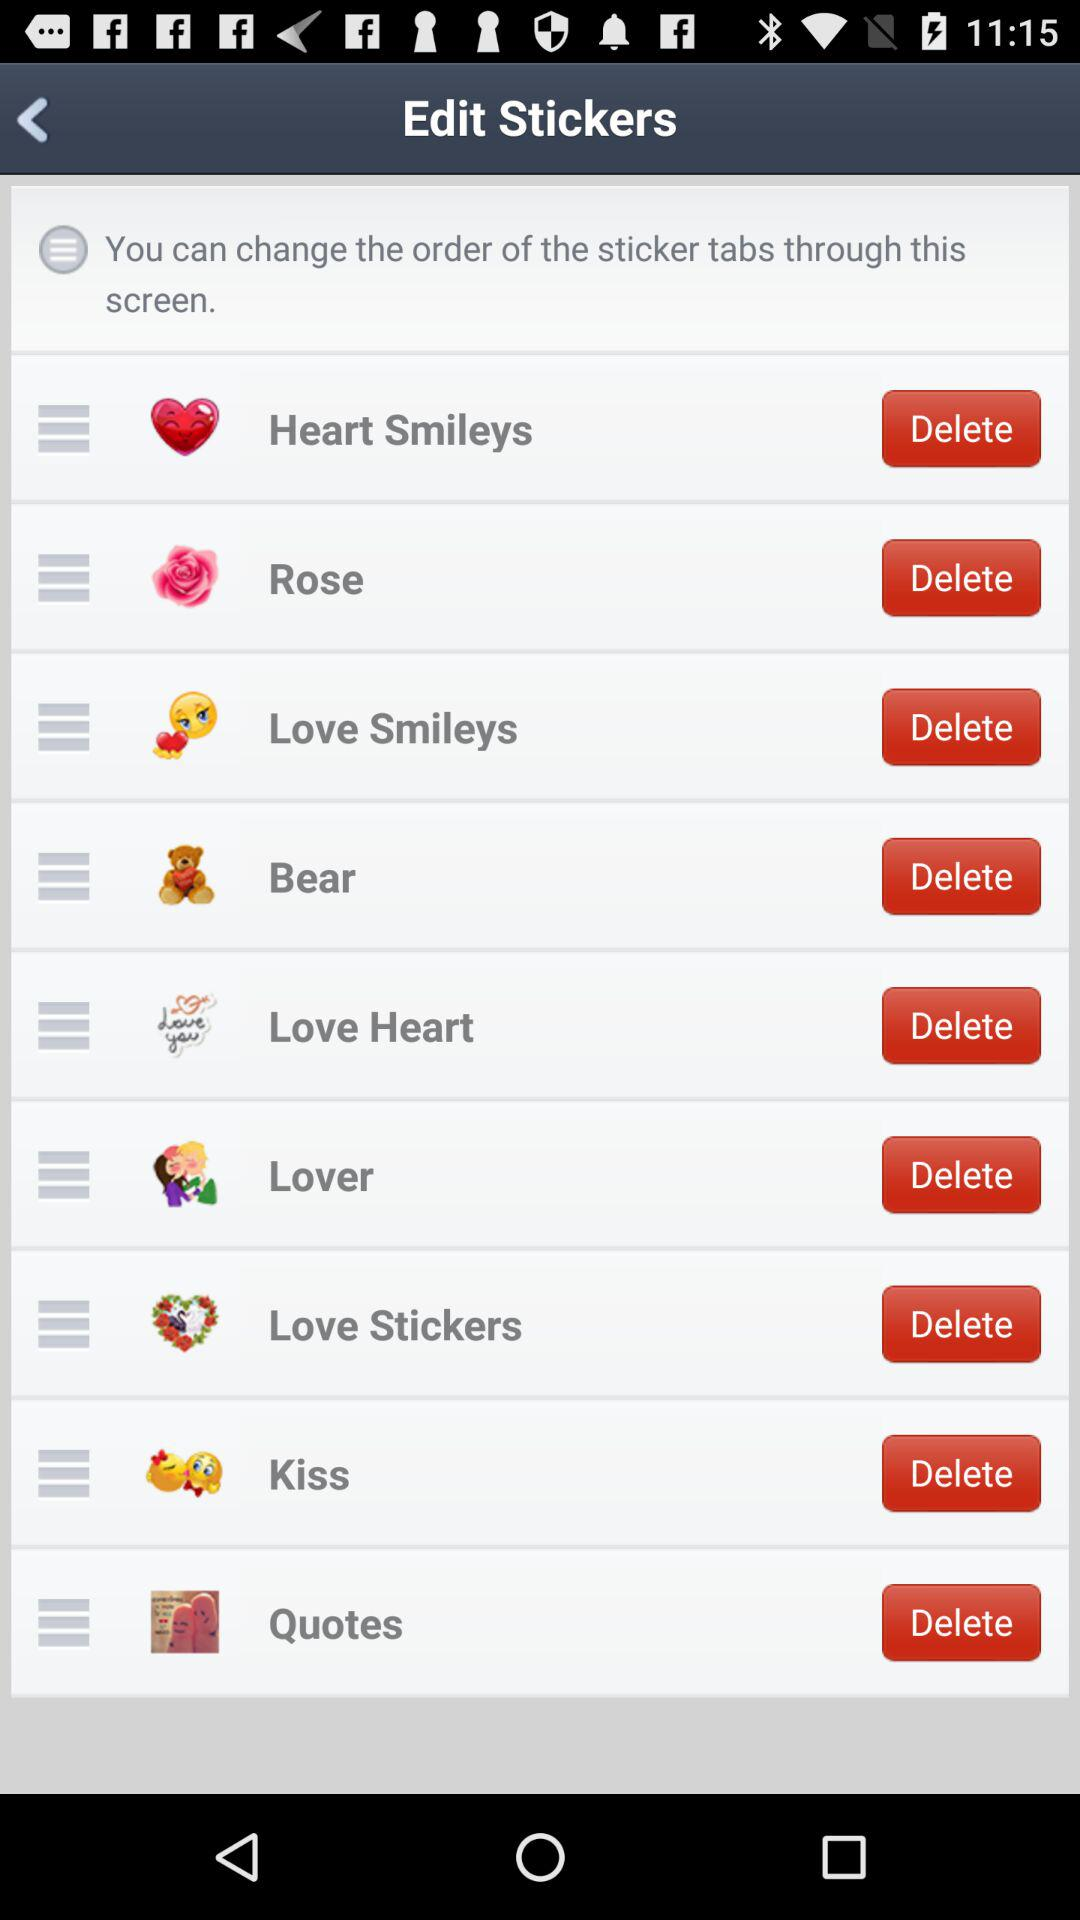How many tabs are there on the screen?
Answer the question using a single word or phrase. 9 